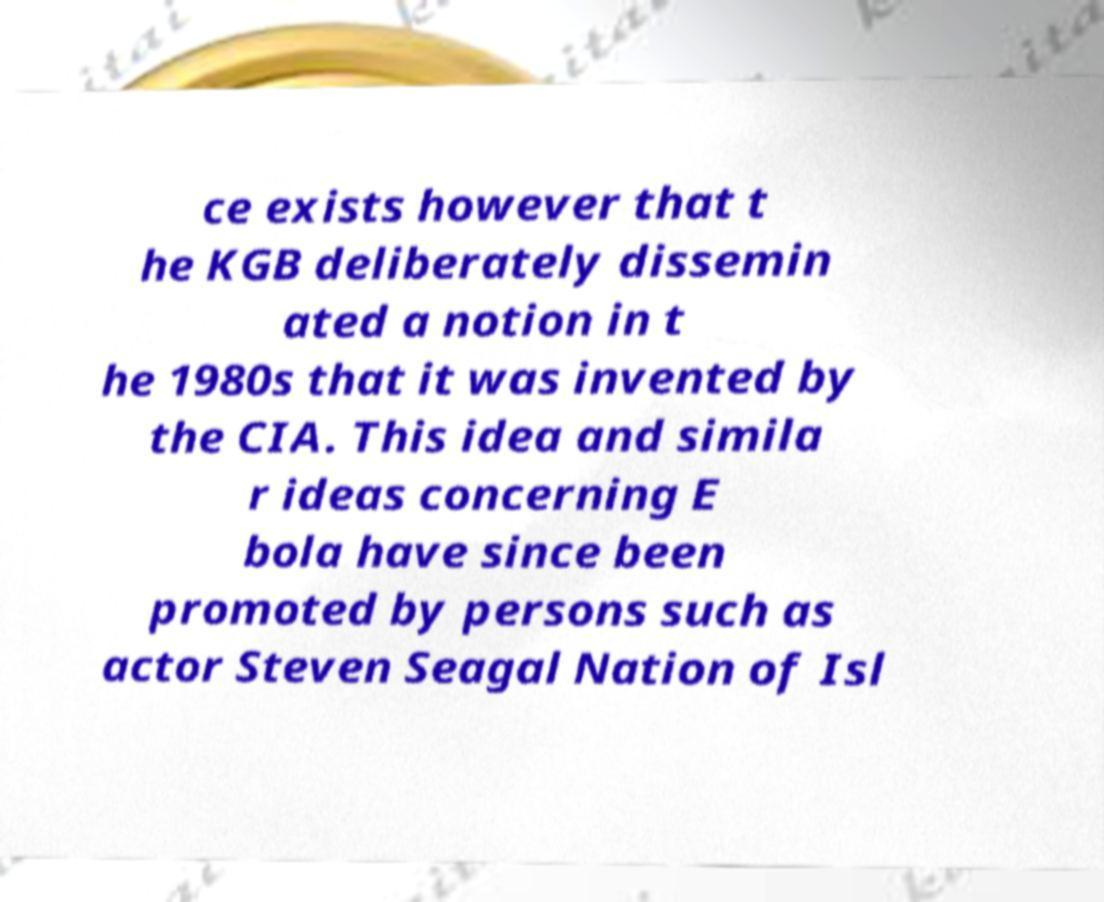Please read and relay the text visible in this image. What does it say? ce exists however that t he KGB deliberately dissemin ated a notion in t he 1980s that it was invented by the CIA. This idea and simila r ideas concerning E bola have since been promoted by persons such as actor Steven Seagal Nation of Isl 